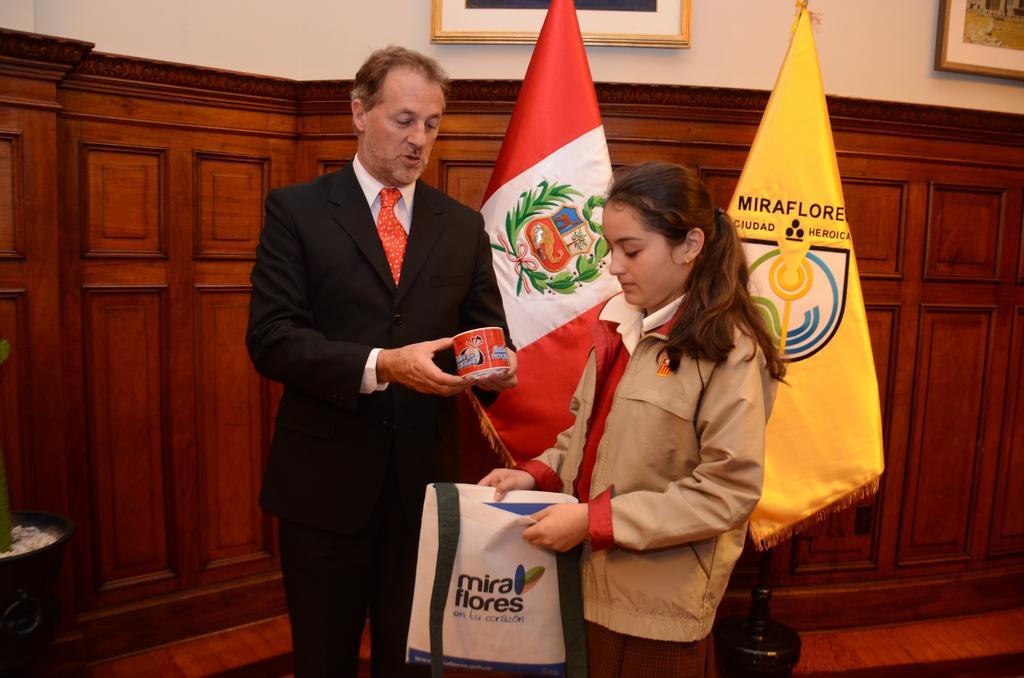In one or two sentences, can you explain what this image depicts? In this picture we can see a girl holding a carry bag. We can see a man holding an object in his hands. There are flags, a flower pot, frames on the walls and a few things in the background. 